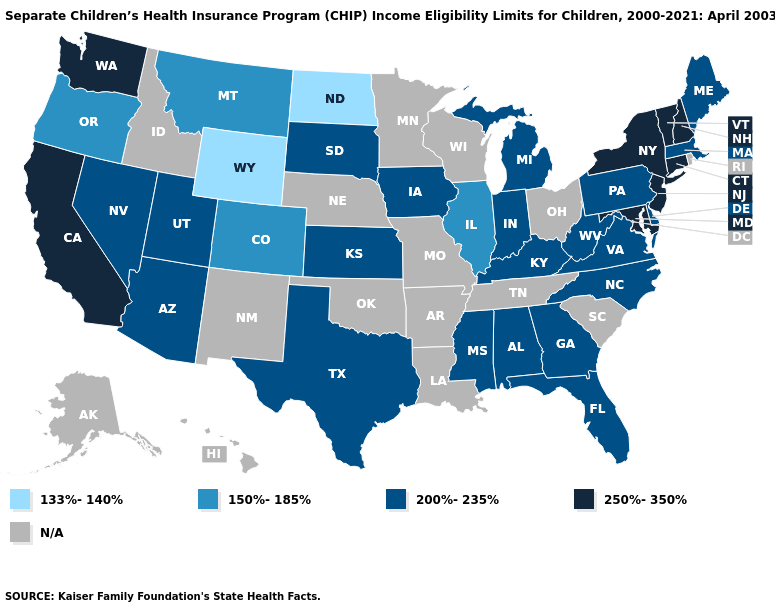Name the states that have a value in the range N/A?
Concise answer only. Alaska, Arkansas, Hawaii, Idaho, Louisiana, Minnesota, Missouri, Nebraska, New Mexico, Ohio, Oklahoma, Rhode Island, South Carolina, Tennessee, Wisconsin. Name the states that have a value in the range 133%-140%?
Be succinct. North Dakota, Wyoming. What is the value of New York?
Write a very short answer. 250%-350%. Name the states that have a value in the range N/A?
Give a very brief answer. Alaska, Arkansas, Hawaii, Idaho, Louisiana, Minnesota, Missouri, Nebraska, New Mexico, Ohio, Oklahoma, Rhode Island, South Carolina, Tennessee, Wisconsin. Does Pennsylvania have the lowest value in the USA?
Write a very short answer. No. What is the value of Arkansas?
Give a very brief answer. N/A. What is the highest value in states that border Mississippi?
Answer briefly. 200%-235%. How many symbols are there in the legend?
Give a very brief answer. 5. Name the states that have a value in the range N/A?
Give a very brief answer. Alaska, Arkansas, Hawaii, Idaho, Louisiana, Minnesota, Missouri, Nebraska, New Mexico, Ohio, Oklahoma, Rhode Island, South Carolina, Tennessee, Wisconsin. What is the value of Michigan?
Quick response, please. 200%-235%. Name the states that have a value in the range 133%-140%?
Short answer required. North Dakota, Wyoming. What is the highest value in states that border Florida?
Be succinct. 200%-235%. What is the highest value in states that border Massachusetts?
Concise answer only. 250%-350%. 